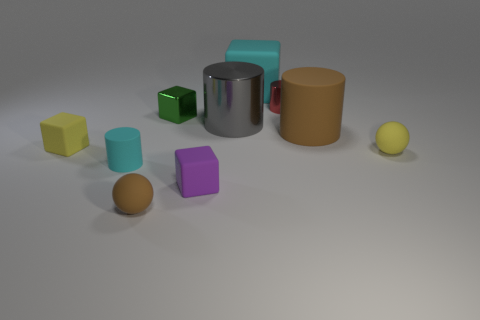Subtract all cubes. How many objects are left? 6 Add 2 small purple rubber cubes. How many small purple rubber cubes are left? 3 Add 9 big gray objects. How many big gray objects exist? 10 Subtract 0 brown blocks. How many objects are left? 10 Subtract all small yellow cylinders. Subtract all metal cubes. How many objects are left? 9 